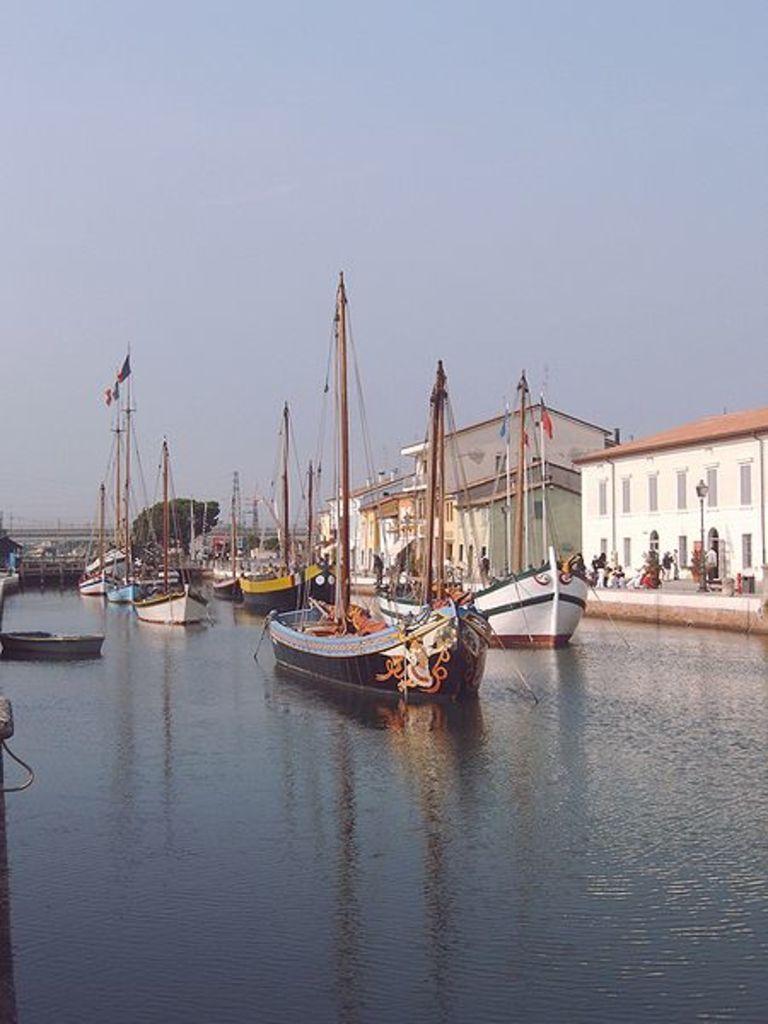In one or two sentences, can you explain what this image depicts? In the center of the image we can see boats on the river. On the right side of the image we can see buildings, persons, road and street lights. In the background we can see ships, bridge and sky. 